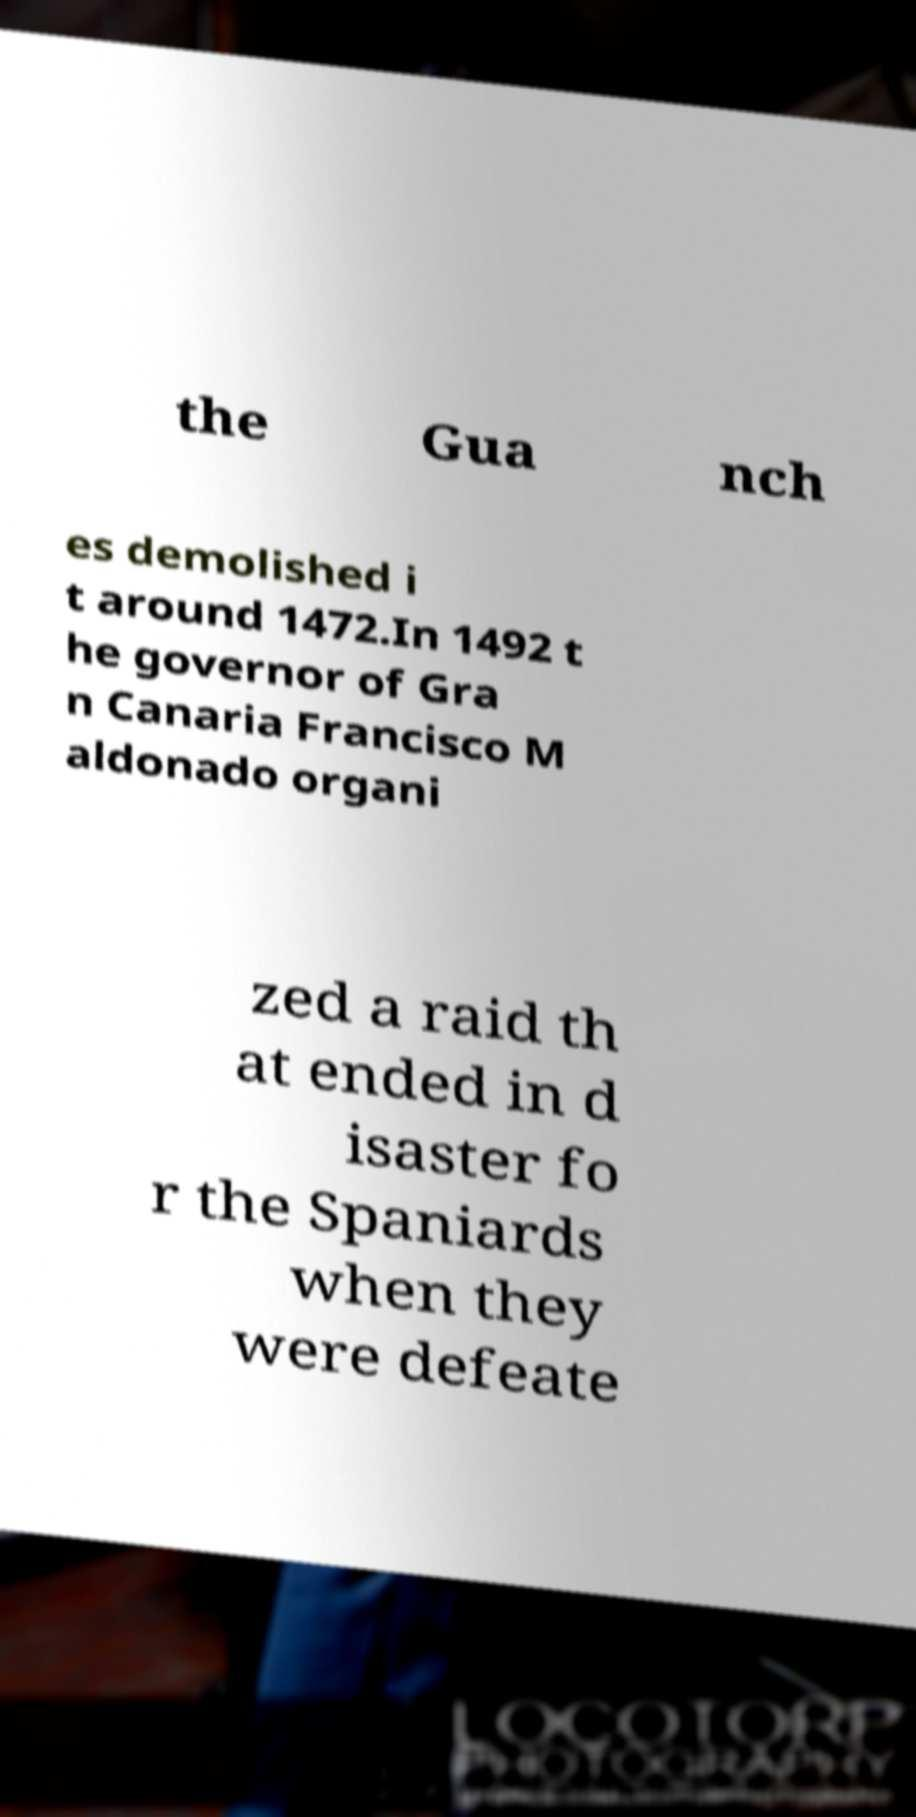Could you extract and type out the text from this image? the Gua nch es demolished i t around 1472.In 1492 t he governor of Gra n Canaria Francisco M aldonado organi zed a raid th at ended in d isaster fo r the Spaniards when they were defeate 